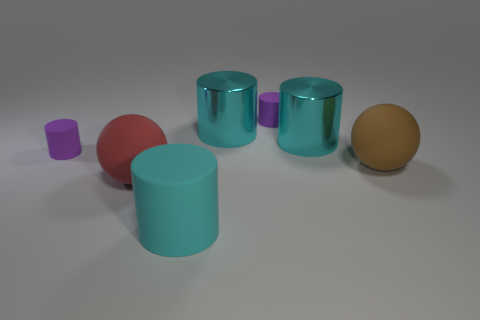How many other things are there of the same shape as the large cyan matte thing?
Give a very brief answer. 4. Is the number of cyan shiny things that are left of the red ball greater than the number of red things?
Your answer should be compact. No. What is the color of the large ball that is in front of the large brown rubber object?
Offer a very short reply. Red. How many shiny objects are tiny purple objects or big red things?
Offer a very short reply. 0. Are there any cyan objects left of the cyan cylinder in front of the large brown rubber sphere on the right side of the red rubber thing?
Your response must be concise. No. What number of small purple rubber objects are in front of the cyan matte object?
Ensure brevity in your answer.  0. What number of large objects are gray matte cylinders or purple things?
Make the answer very short. 0. There is a purple rubber object that is left of the big cyan matte cylinder; what shape is it?
Provide a succinct answer. Cylinder. Is there a metallic cylinder that has the same color as the large matte cylinder?
Provide a succinct answer. Yes. There is a cylinder in front of the brown object; is its size the same as the matte ball in front of the large brown sphere?
Offer a terse response. Yes. 